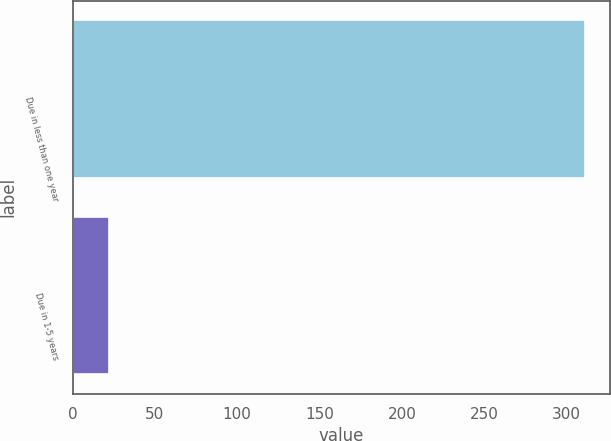<chart> <loc_0><loc_0><loc_500><loc_500><bar_chart><fcel>Due in less than one year<fcel>Due in 1-5 years<nl><fcel>311<fcel>22<nl></chart> 